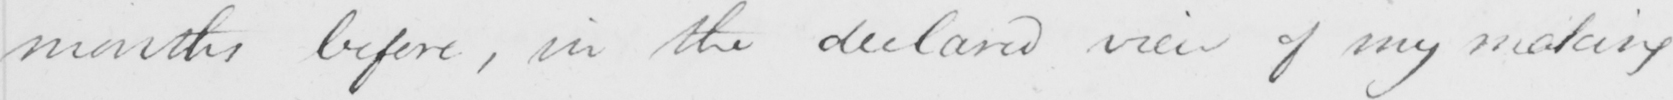Can you read and transcribe this handwriting? months before , in the declared view of my making 